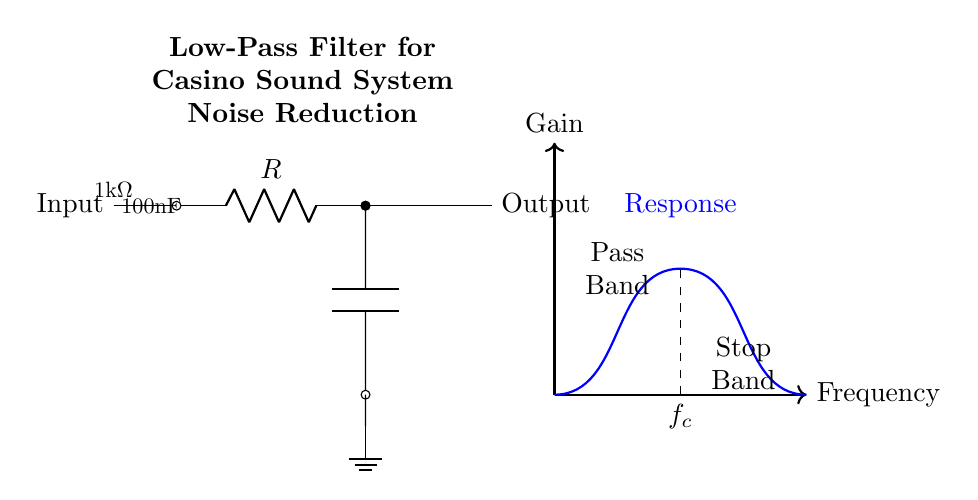What type of circuit is shown? The diagram represents a low-pass filter circuit, which is characterized by its ability to allow low-frequency signals to pass while attenuating higher frequencies.
Answer: low-pass filter What is the resistance value? The resistance value indicated in the circuit diagram is 1 kOhm, as labeled next to the resistor symbol.
Answer: 1 kOhm What is the capacitance value? The circuit presents a capacitance value of 100 nF, which is marked next to the capacitor symbol in the diagram.
Answer: 100 nF What does the dashed line indicate? The dashed line in the diagram marks the cutoff frequency, represented by the symbol f_c, which is the frequency at which the output signal begins to decrease significantly.
Answer: f_c What are the two main frequency ranges labeled? The two frequency ranges labeled in the diagram are "Pass Band" and "Stop Band," indicating the frequencies the filter allows through and those it blocks, respectively.
Answer: Pass Band and Stop Band At what point does the gain begin to drop? The gain begins to drop right after the cutoff frequency f_c, which is visualized in the frequency response curve in the diagram.
Answer: f_c How does this filter help in casino sound systems? This filter helps reduce unwanted high-frequency noise in casino sound systems, thereby enhancing the clarity of the desired audio signals like announcements and music.
Answer: noise reduction 